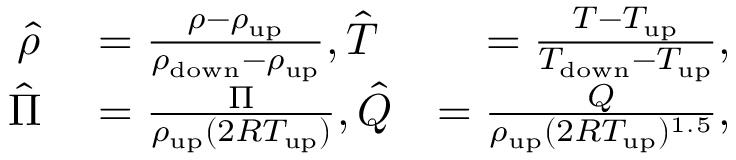<formula> <loc_0><loc_0><loc_500><loc_500>\begin{array} { r l r } { \hat { \rho } } & = \frac { \rho - \rho _ { u p } } { \rho _ { d o w n } - \rho _ { u p } } , \hat { T } } & { = \frac { T - T _ { u p } } { T _ { d o w n } - T _ { u p } } , } \\ { \hat { \Pi } } & = \frac { \Pi } { \rho _ { u p } ( 2 R T _ { u p } ) } , \hat { Q } } & { = \frac { Q } { \rho _ { u p } ( 2 R T _ { u p } ) ^ { 1 . 5 } } , } \end{array}</formula> 